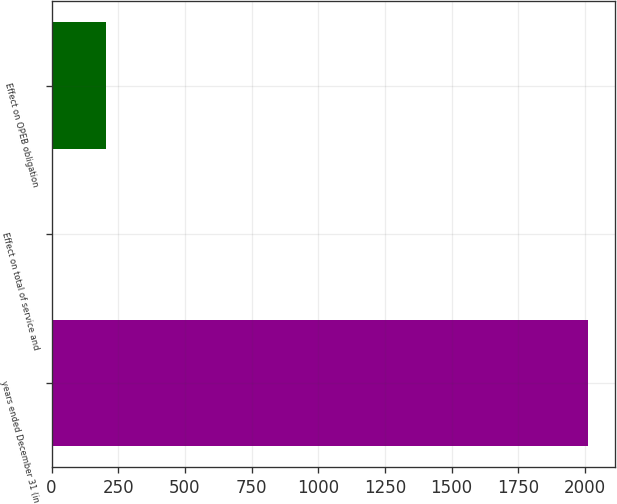<chart> <loc_0><loc_0><loc_500><loc_500><bar_chart><fcel>years ended December 31 (in<fcel>Effect on total of service and<fcel>Effect on OPEB obligation<nl><fcel>2012<fcel>5<fcel>205.7<nl></chart> 